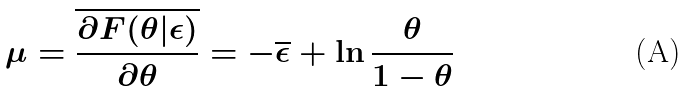Convert formula to latex. <formula><loc_0><loc_0><loc_500><loc_500>\mu = { \overline { \frac { \partial F ( \theta | \epsilon ) } { \partial \theta } } } = - { \overline { \epsilon } } + \ln { \frac { \theta } { 1 - \theta } }</formula> 